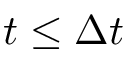Convert formula to latex. <formula><loc_0><loc_0><loc_500><loc_500>t \leq \Delta t</formula> 